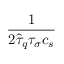Convert formula to latex. <formula><loc_0><loc_0><loc_500><loc_500>\frac { 1 } { 2 \hat { \tau } _ { q } \tau _ { \sigma } c _ { s } }</formula> 